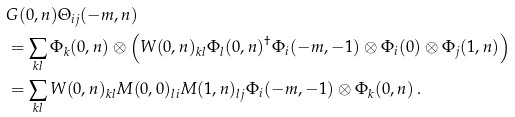Convert formula to latex. <formula><loc_0><loc_0><loc_500><loc_500>& G ( 0 , n ) \Theta _ { i j } ( - m , n ) \\ & = \sum _ { k l } \Phi _ { k } ( 0 , n ) \otimes \left ( W ( 0 , n ) _ { k l } \Phi _ { l } ( 0 , n ) ^ { \dagger } \Phi _ { i } ( - m , - 1 ) \otimes \Phi _ { i } ( 0 ) \otimes \Phi _ { j } ( 1 , n ) \right ) \\ & = \sum _ { k l } W ( 0 , n ) _ { k l } M ( 0 , 0 ) _ { l i } M ( 1 , n ) _ { l j } \Phi _ { i } ( - m , - 1 ) \otimes \Phi _ { k } ( 0 , n ) \, .</formula> 